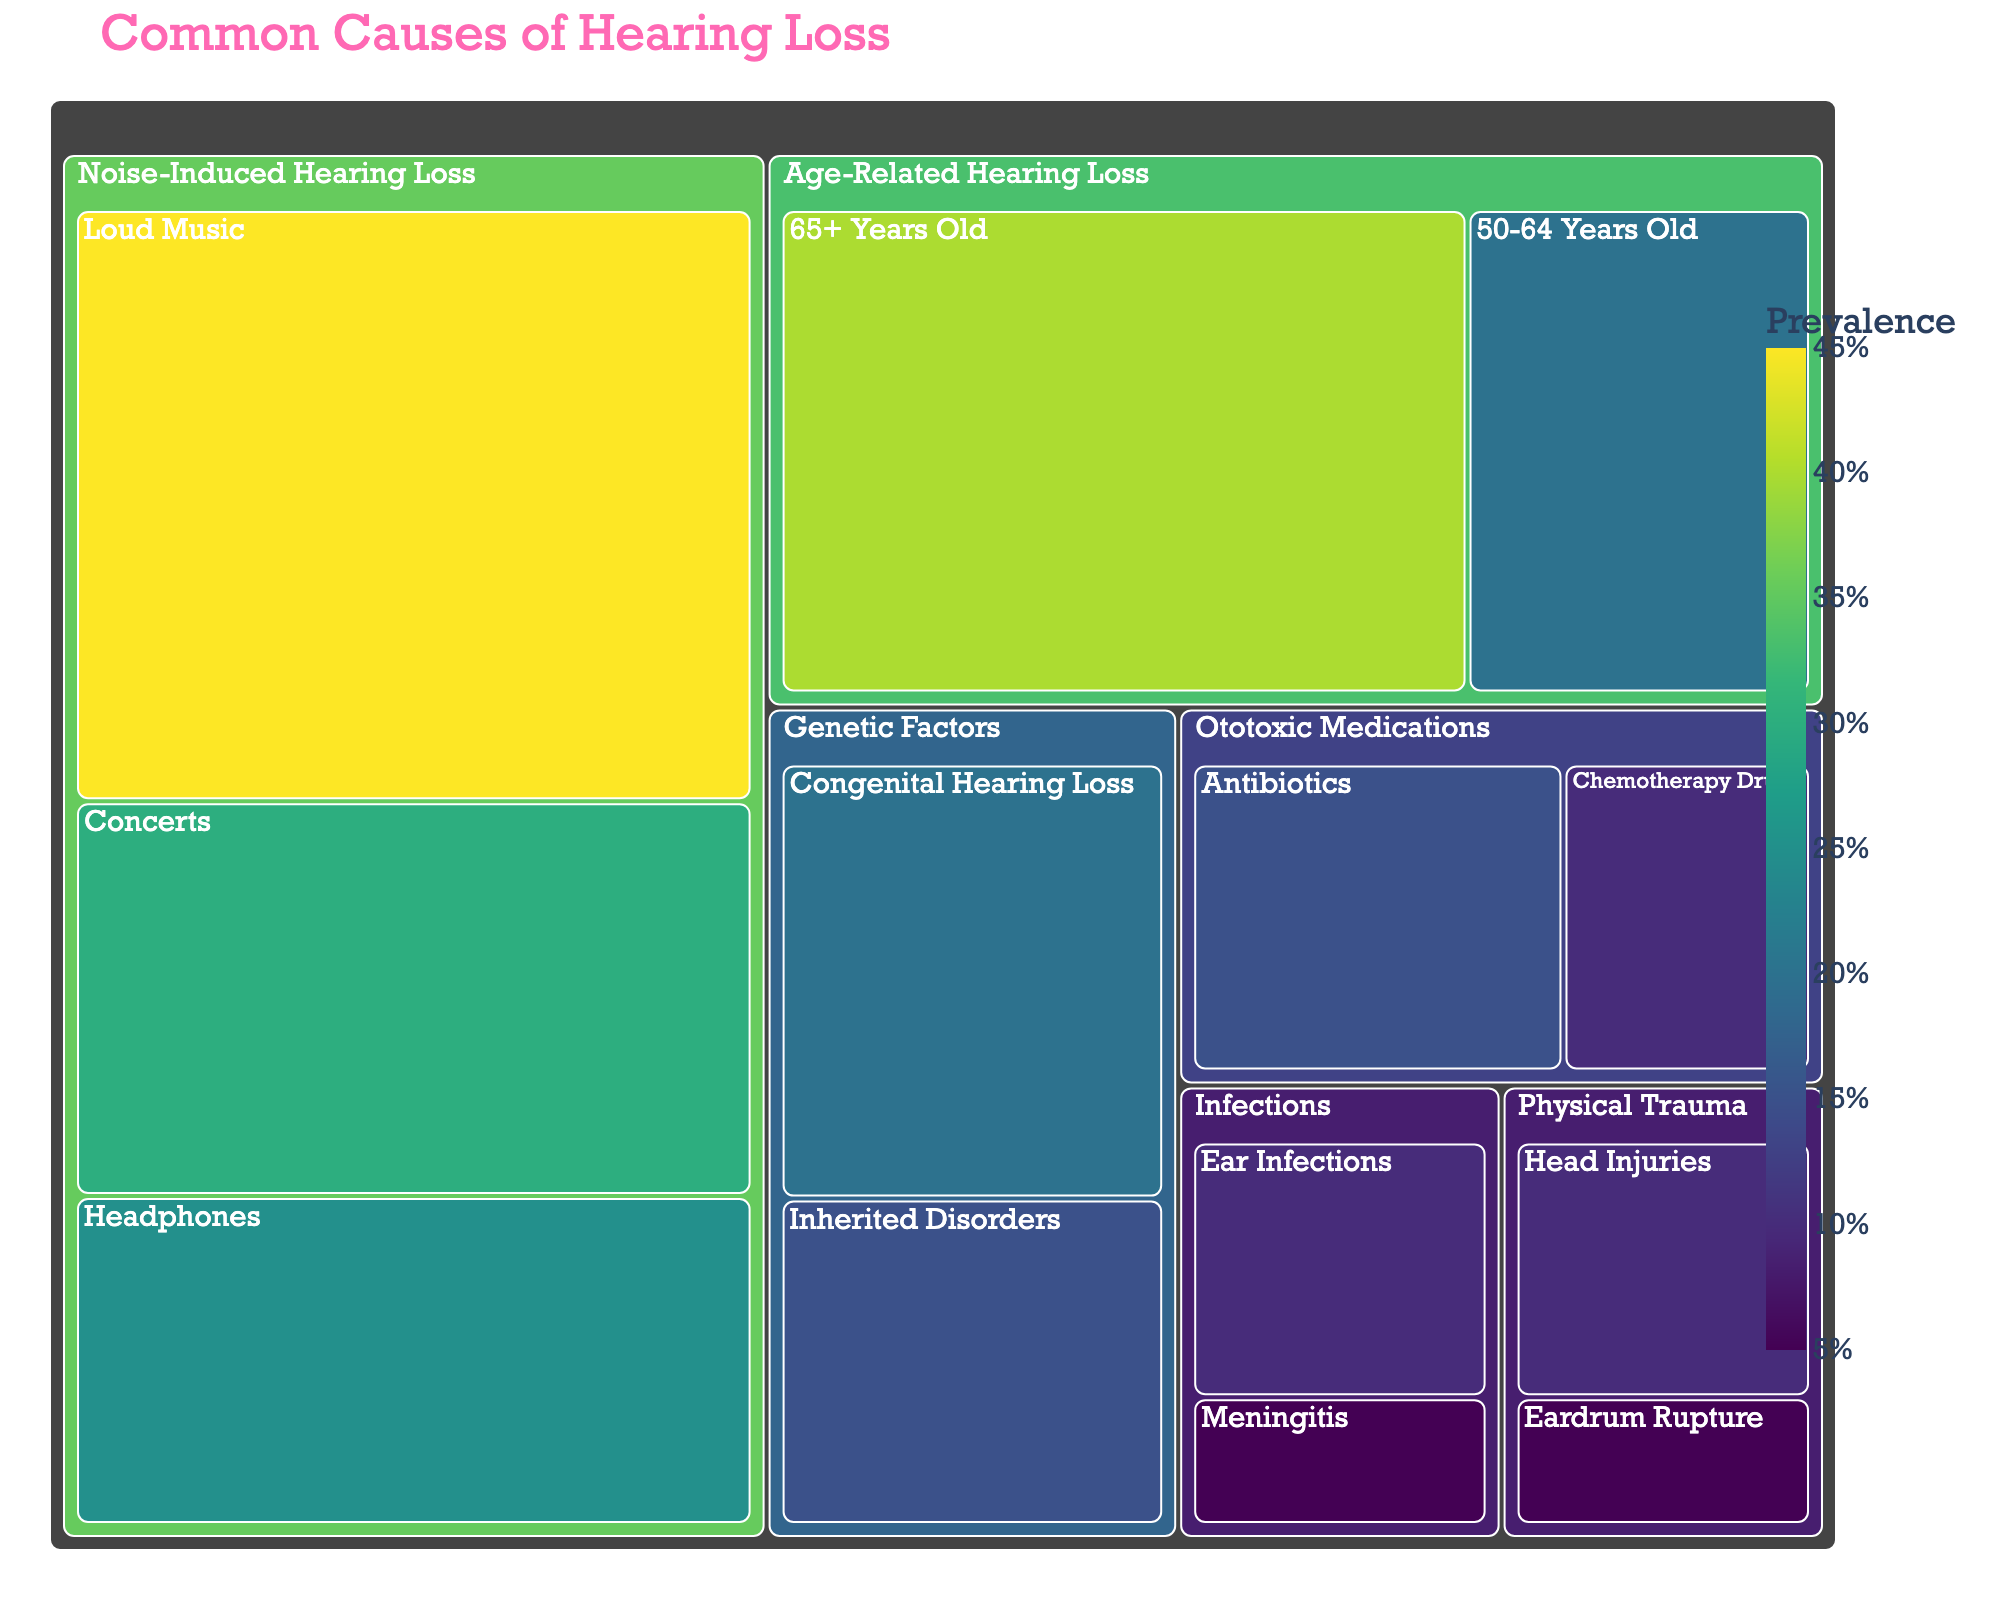What is the title of the treemap? The title of the treemap is prominently displayed at the top of the figure.
Answer: Common Causes of Hearing Loss Which subcategory has the highest value in the category "Noise-Induced Hearing Loss"? Locate the "Noise-Induced Hearing Loss" category, and then look for the subcategory with the highest percentage value within it.
Answer: Loud Music What is the total value for the category "Genetic Factors"? Sum the values of the subcategories "Congenital Hearing Loss" and "Inherited Disorders" under the "Genetic Factors" category. 20 + 15 = 35
Answer: 35% Which has a higher value: "Age-Related Hearing Loss" in the "65+ Years Old" subcategory or "Concerts" under "Noise-Induced Hearing Loss"? Compare the values of these two subcategories directly. 40 (65+ Years Old) vs. 30 (Concerts).
Answer: Age-Related Hearing Loss (65+ Years Old) How does the value of "Headphones" compare to "Eardrum Rupture"? Look at the values for "Headphones" under "Noise-Induced Hearing Loss" and "Eardrum Rupture" under "Physical Trauma". 25 (Headphones) is greater than 5 (Eardrum Rupture).
Answer: Headphones has a higher value What percentage of hearing loss is attributed to concerts? Locate the subcategory "Concerts" under "Noise-Induced Hearing Loss", which has a value of 30%.
Answer: 30% Which category has the smallest total value, and what is that value? Sum the values of each subcategory under each category, and then determine which category has the smallest total. The smallest category is "Infections" (10 + 5 = 15).
Answer: Infections, 15% What is the combined value of "Ototoxic Medications"? Add the values of "Antibiotics" and "Chemotherapy Drugs". 15 + 10 = 25
Answer: 25% Identify the two subcategories under "Physical Trauma" and their values. Refer to the "Physical Trauma" category and note the values of its subcategories, which are "Head Injuries" and "Eardrum Rupture".
Answer: Head Injuries: 10%, Eardrum Rupture: 5% Sum the values of all subcategories under "Noise-Induced Hearing Loss". Add the values for "Loud Music," "Concerts," and "Headphones." 45 + 30 + 25 = 100
Answer: 100% 